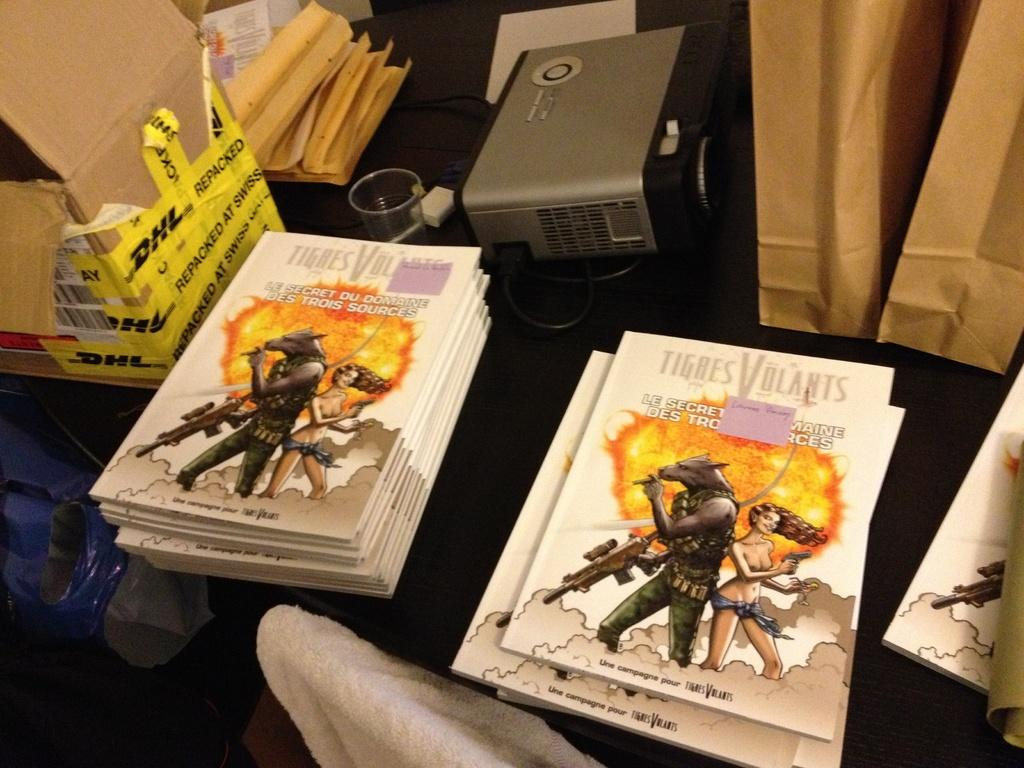<image>
Share a concise interpretation of the image provided. A book titled Tigres Volants has a creature with a gun on the cover. 